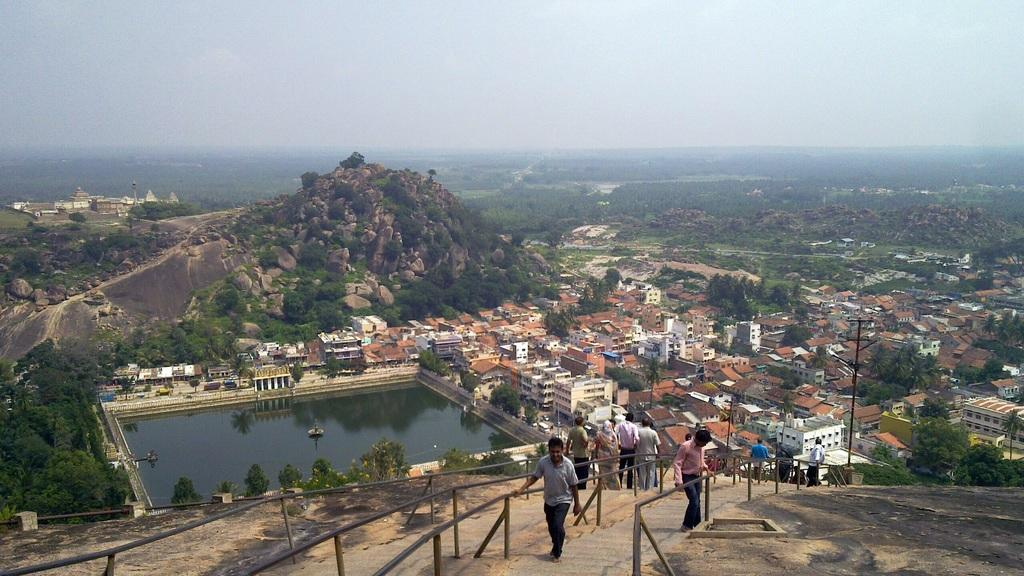What can be seen in the foreground of the image? There are people, buildings, and water in the foreground of the image. What is visible in the background of the image? There are mountains, greenery, and the sky in the background of the image. Can you describe the setting of the image? The image features a scene with people, buildings, and water in the foreground, and mountains, greenery, and the sky in the background. What type of lead is being used by the people in the image? There is no indication of any lead being used by the people in the image. Can you tell me where the mailbox is located in the image? There is no mailbox present in the image. 